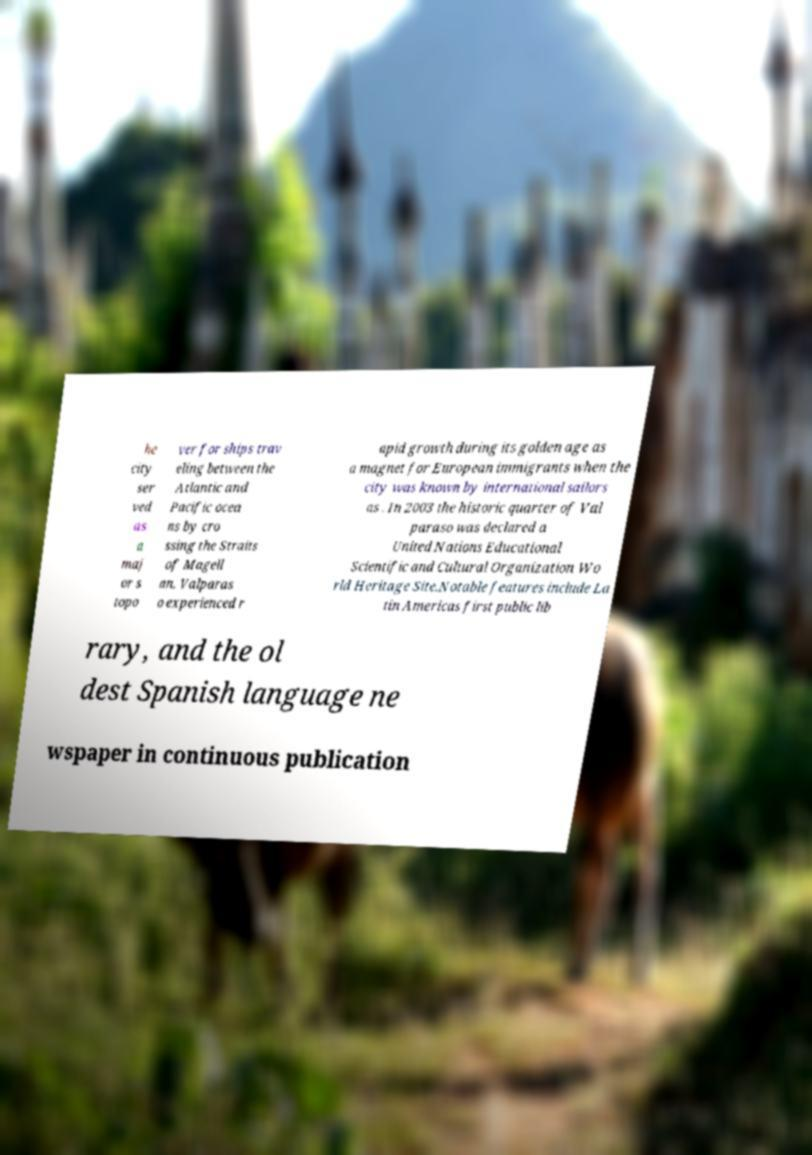Could you extract and type out the text from this image? he city ser ved as a maj or s topo ver for ships trav eling between the Atlantic and Pacific ocea ns by cro ssing the Straits of Magell an. Valparas o experienced r apid growth during its golden age as a magnet for European immigrants when the city was known by international sailors as . In 2003 the historic quarter of Val paraso was declared a United Nations Educational Scientific and Cultural Organization Wo rld Heritage Site.Notable features include La tin Americas first public lib rary, and the ol dest Spanish language ne wspaper in continuous publication 